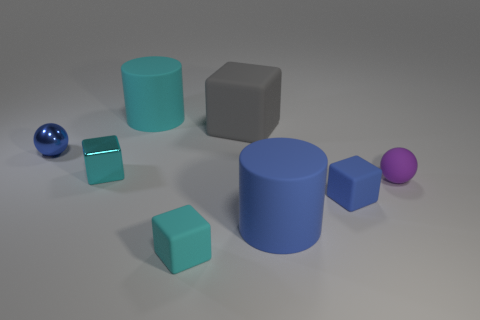How many other objects are the same color as the tiny matte sphere?
Your response must be concise. 0. Does the tiny ball that is right of the metallic sphere have the same color as the metal ball?
Provide a succinct answer. No. There is a purple ball that is made of the same material as the large gray cube; what size is it?
Keep it short and to the point. Small. There is a cylinder left of the gray thing; is its size the same as the small blue rubber thing?
Offer a terse response. No. The cylinder that is the same color as the metallic block is what size?
Offer a very short reply. Large. Is there a rubber cube that has the same color as the tiny shiny cube?
Offer a very short reply. Yes. Are there more tiny cyan cubes in front of the large blue matte cylinder than big yellow metal cylinders?
Offer a terse response. Yes. Is the shape of the tiny blue matte object the same as the big object that is on the left side of the gray cube?
Offer a very short reply. No. Is there a tiny rubber thing?
Your answer should be very brief. Yes. How many large objects are blue cylinders or blue rubber cubes?
Your answer should be very brief. 1. 